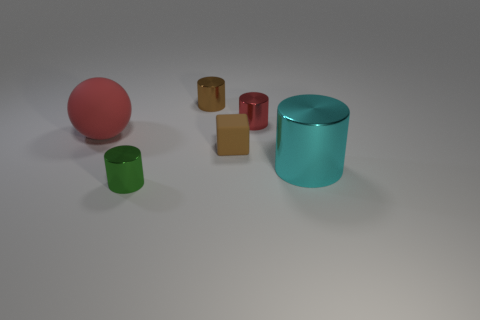What number of tiny metal cylinders are in front of the big cyan cylinder and on the right side of the tiny brown metal thing?
Your response must be concise. 0. What is the shape of the metallic object that is in front of the cyan metal cylinder?
Make the answer very short. Cylinder. Are there fewer metal cylinders that are on the right side of the small block than objects right of the red rubber object?
Your answer should be compact. Yes. Are the small cylinder that is in front of the cyan metal cylinder and the red object on the right side of the green cylinder made of the same material?
Offer a terse response. Yes. There is a big red rubber object; what shape is it?
Provide a succinct answer. Sphere. Is the number of cylinders to the left of the brown block greater than the number of green things that are behind the big rubber object?
Your answer should be compact. Yes. There is a rubber thing on the left side of the brown block; does it have the same shape as the shiny object that is in front of the cyan shiny object?
Offer a very short reply. No. How many other things are the same size as the brown block?
Keep it short and to the point. 3. How big is the brown cube?
Offer a very short reply. Small. Does the object that is to the left of the green metal cylinder have the same material as the brown block?
Provide a short and direct response. Yes. 